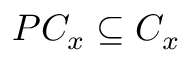Convert formula to latex. <formula><loc_0><loc_0><loc_500><loc_500>P C _ { x } \subseteq C _ { x }</formula> 